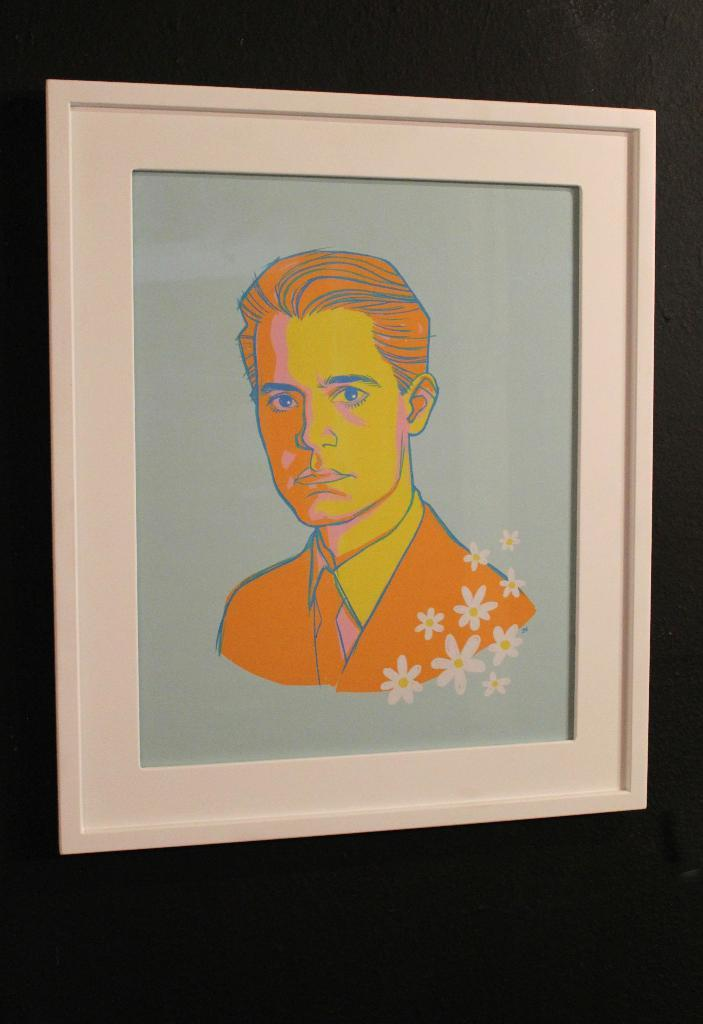What is the main subject in the center of the image? There is a photo frame in the center of the image. What is inside the photo frame? The photo frame contains a depiction of a person. How do the planes in the image maintain harmony with the person depicted in the photo frame? There are no planes present in the image, so the question of harmony between planes and the person depicted in the photo frame is not applicable. 